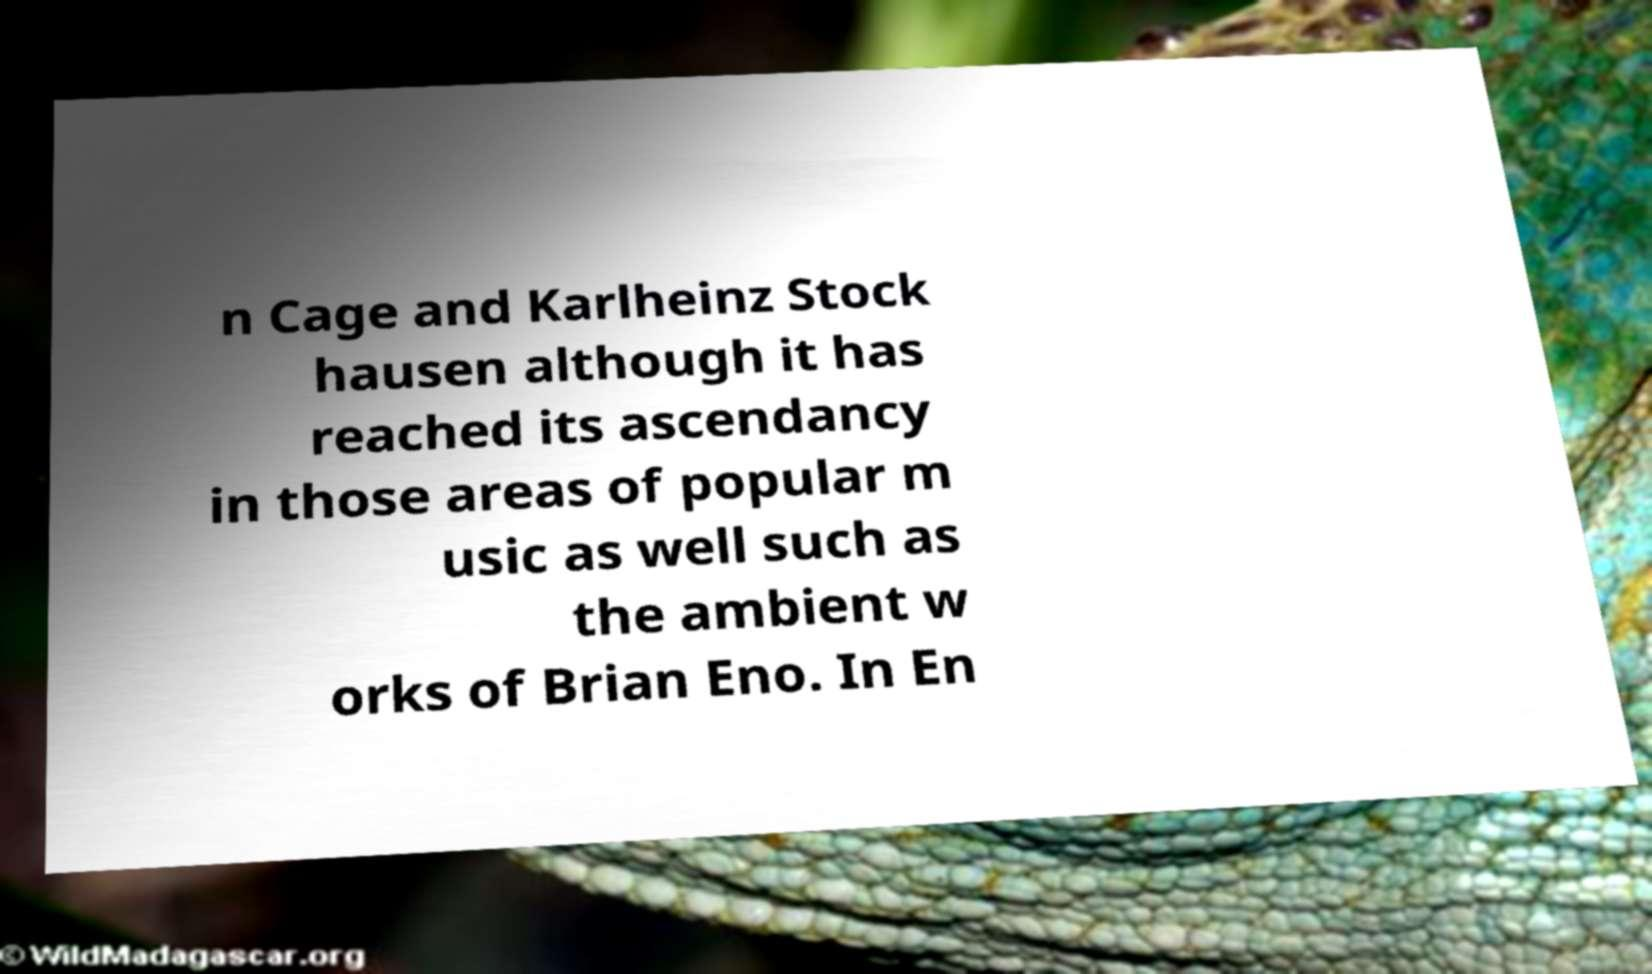Could you assist in decoding the text presented in this image and type it out clearly? n Cage and Karlheinz Stock hausen although it has reached its ascendancy in those areas of popular m usic as well such as the ambient w orks of Brian Eno. In En 